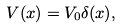<formula> <loc_0><loc_0><loc_500><loc_500>V ( x ) = V _ { 0 } \delta ( x ) ,</formula> 